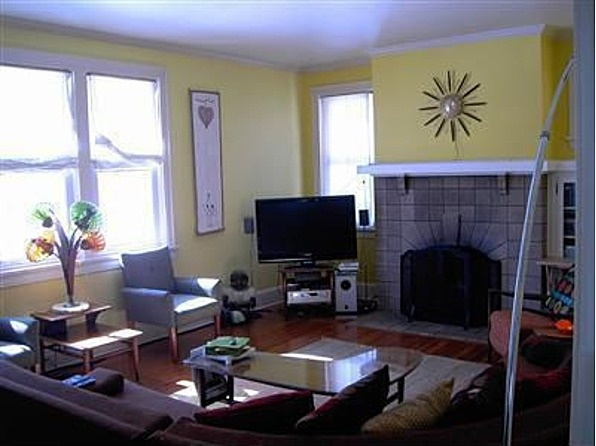Describe the objects in this image and their specific colors. I can see couch in darkgray, black, and gray tones, couch in darkgray, black, and purple tones, tv in darkgray, black, and gray tones, chair in darkgray, gray, black, and white tones, and chair in darkgray, black, maroon, gray, and purple tones in this image. 